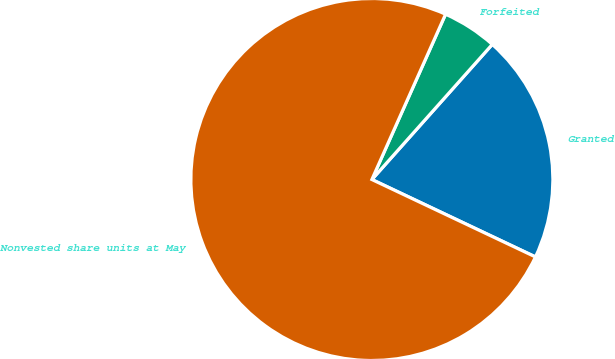Convert chart. <chart><loc_0><loc_0><loc_500><loc_500><pie_chart><fcel>Granted<fcel>Forfeited<fcel>Nonvested share units at May<nl><fcel>20.45%<fcel>4.91%<fcel>74.64%<nl></chart> 